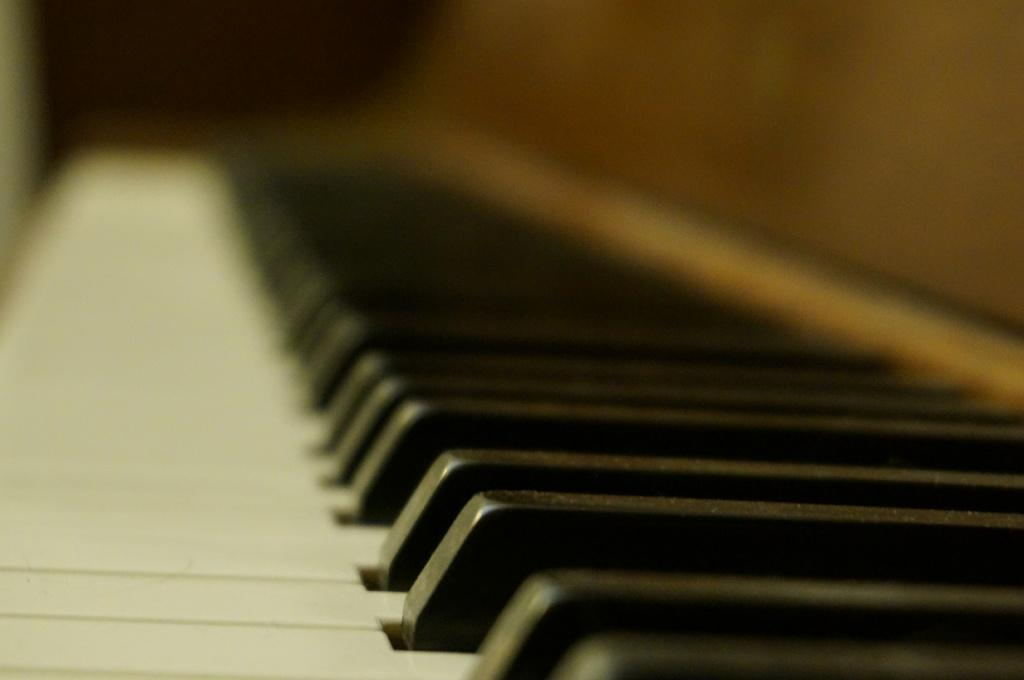What musical instrument is present in the image? There is a piano in the image. What type of insect can be seen crawling on the piano keys in the image? There is no insect present on the piano keys in the image. 